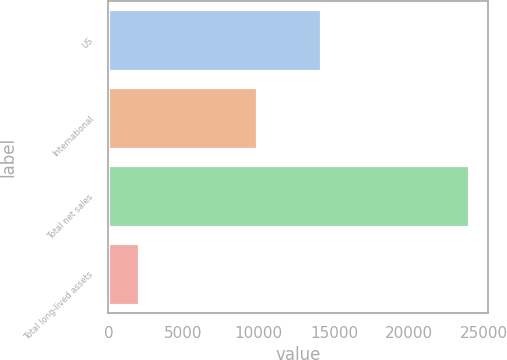Convert chart to OTSL. <chart><loc_0><loc_0><loc_500><loc_500><bar_chart><fcel>US<fcel>International<fcel>Total net sales<fcel>Total long-lived assets<nl><fcel>14128<fcel>9878<fcel>24006<fcel>2012<nl></chart> 